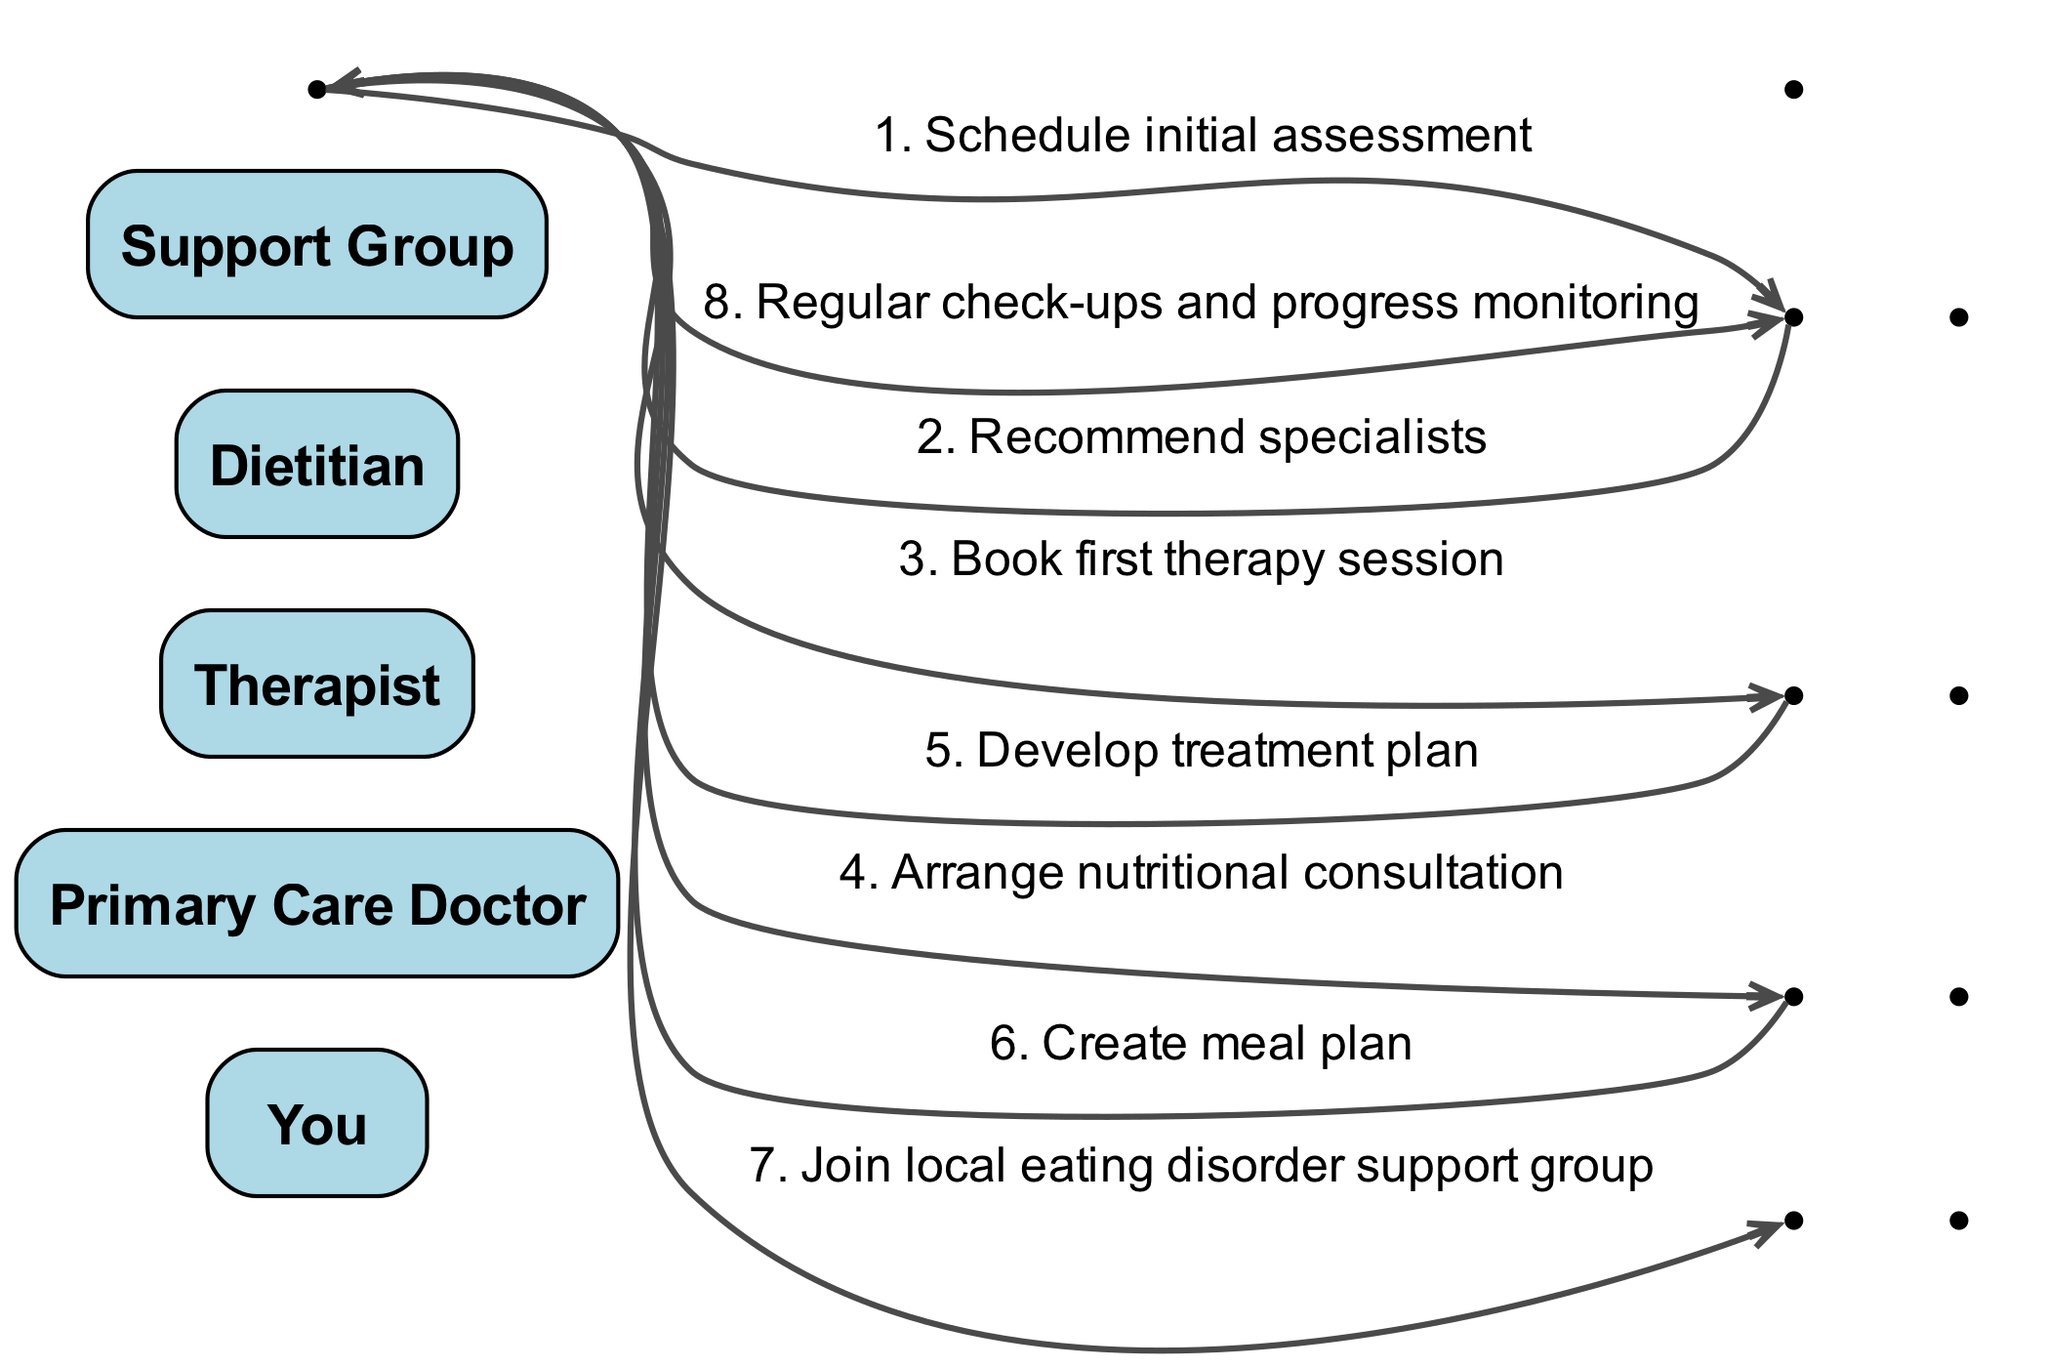What is the first action taken in the recovery process? The first action is to schedule an initial assessment with the primary care doctor, as depicted by the first step in the sequence.
Answer: Schedule initial assessment Who is recommended by the primary care doctor? The primary care doctor recommends specialists to the individual, which is the second step in the sequence.
Answer: Specialists What are the two professionals you book sessions with after the initial assessment? After the initial assessment, the individual books a therapy session with the therapist and arranges a nutritional consultation with the dietitian, seen in steps three and four.
Answer: Therapist and Dietitian How many total steps are there in the sequence? The total number of steps in the sequence is eight, counting from the initial assessment to regular check-ups.
Answer: Eight What is the purpose of the meal plan created by the dietitian? The meal plan created by the dietitian serves to provide structured nutritional guidance, shown as a direct message from the dietitian to the individual in the sequence.
Answer: Create meal plan What does the therapist develop for the individual during the process? The therapist develops a treatment plan for the individual, which is the fifth step in the diagram.
Answer: Treatment plan What is the final step in the sequence of seeking professional support? The final step listed in the sequence is regular check-ups and progress monitoring with the primary care doctor.
Answer: Regular check-ups and progress monitoring How many times does the individual interact with the primary care doctor? The individual interacts with the primary care doctor twice throughout the sequence: first to schedule the initial assessment and then for regular check-ups.
Answer: Twice 